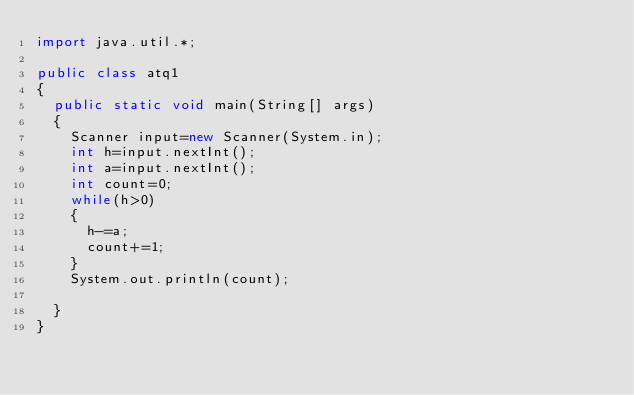Convert code to text. <code><loc_0><loc_0><loc_500><loc_500><_Java_>import java.util.*;

public class atq1
{
	public static void main(String[] args)
	{
		Scanner input=new Scanner(System.in);
		int h=input.nextInt();
		int a=input.nextInt();
		int count=0;
		while(h>0)
		{
			h-=a;
			count+=1;
		}
		System.out.println(count);

	}
}</code> 